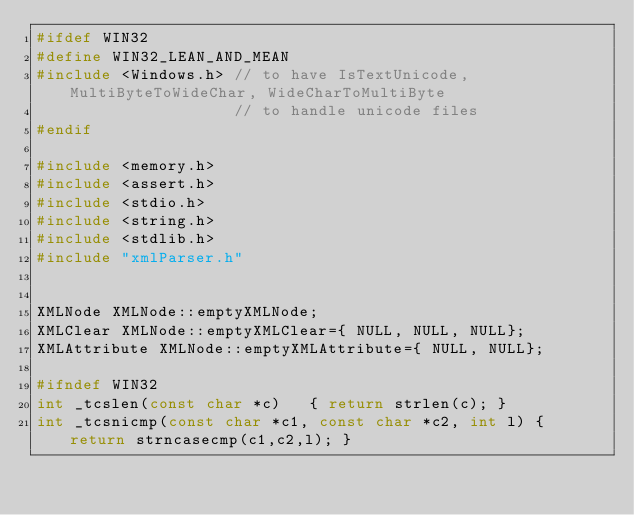Convert code to text. <code><loc_0><loc_0><loc_500><loc_500><_C++_>#ifdef WIN32
#define WIN32_LEAN_AND_MEAN
#include <Windows.h> // to have IsTextUnicode, MultiByteToWideChar, WideCharToMultiByte
                     // to handle unicode files
#endif

#include <memory.h>
#include <assert.h>
#include <stdio.h>
#include <string.h>
#include <stdlib.h>
#include "xmlParser.h"


XMLNode XMLNode::emptyXMLNode;
XMLClear XMLNode::emptyXMLClear={ NULL, NULL, NULL};
XMLAttribute XMLNode::emptyXMLAttribute={ NULL, NULL};

#ifndef WIN32
int _tcslen(const char *c)   { return strlen(c); }
int _tcsnicmp(const char *c1, const char *c2, int l) { return strncasecmp(c1,c2,l); }</code> 